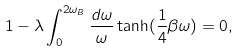Convert formula to latex. <formula><loc_0><loc_0><loc_500><loc_500>1 - \lambda \int _ { 0 } ^ { 2 \omega _ { B } } \frac { d \omega } { \omega } \tanh ( \frac { 1 } { 4 } \beta \omega ) = 0 ,</formula> 